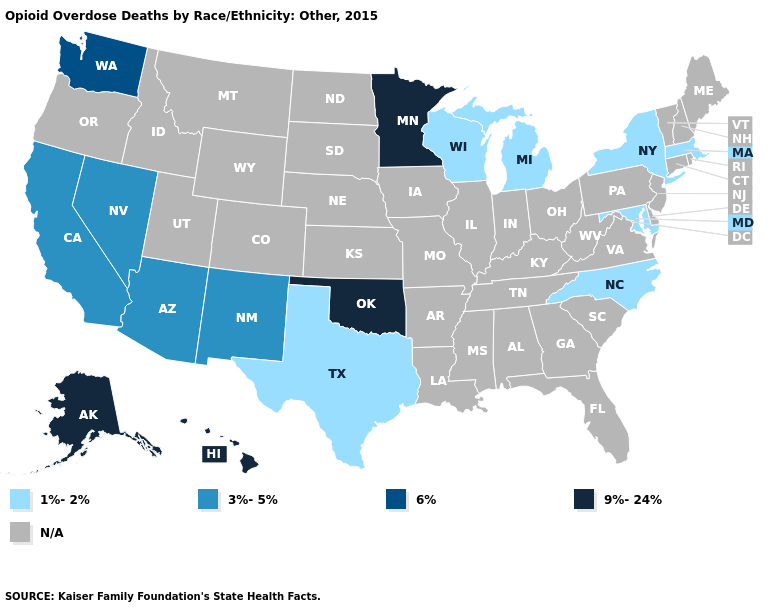Is the legend a continuous bar?
Keep it brief. No. Name the states that have a value in the range 6%?
Short answer required. Washington. What is the value of Connecticut?
Give a very brief answer. N/A. How many symbols are there in the legend?
Quick response, please. 5. What is the value of Rhode Island?
Keep it brief. N/A. Among the states that border Connecticut , which have the highest value?
Short answer required. Massachusetts, New York. Which states have the lowest value in the USA?
Keep it brief. Maryland, Massachusetts, Michigan, New York, North Carolina, Texas, Wisconsin. Does Wisconsin have the lowest value in the MidWest?
Concise answer only. Yes. Which states have the highest value in the USA?
Keep it brief. Alaska, Hawaii, Minnesota, Oklahoma. Name the states that have a value in the range 3%-5%?
Quick response, please. Arizona, California, Nevada, New Mexico. What is the value of North Carolina?
Quick response, please. 1%-2%. What is the value of Maryland?
Answer briefly. 1%-2%. What is the highest value in the USA?
Short answer required. 9%-24%. 